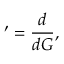Convert formula to latex. <formula><loc_0><loc_0><loc_500><loc_500>^ { \prime } = \frac { d } { d G } ,</formula> 